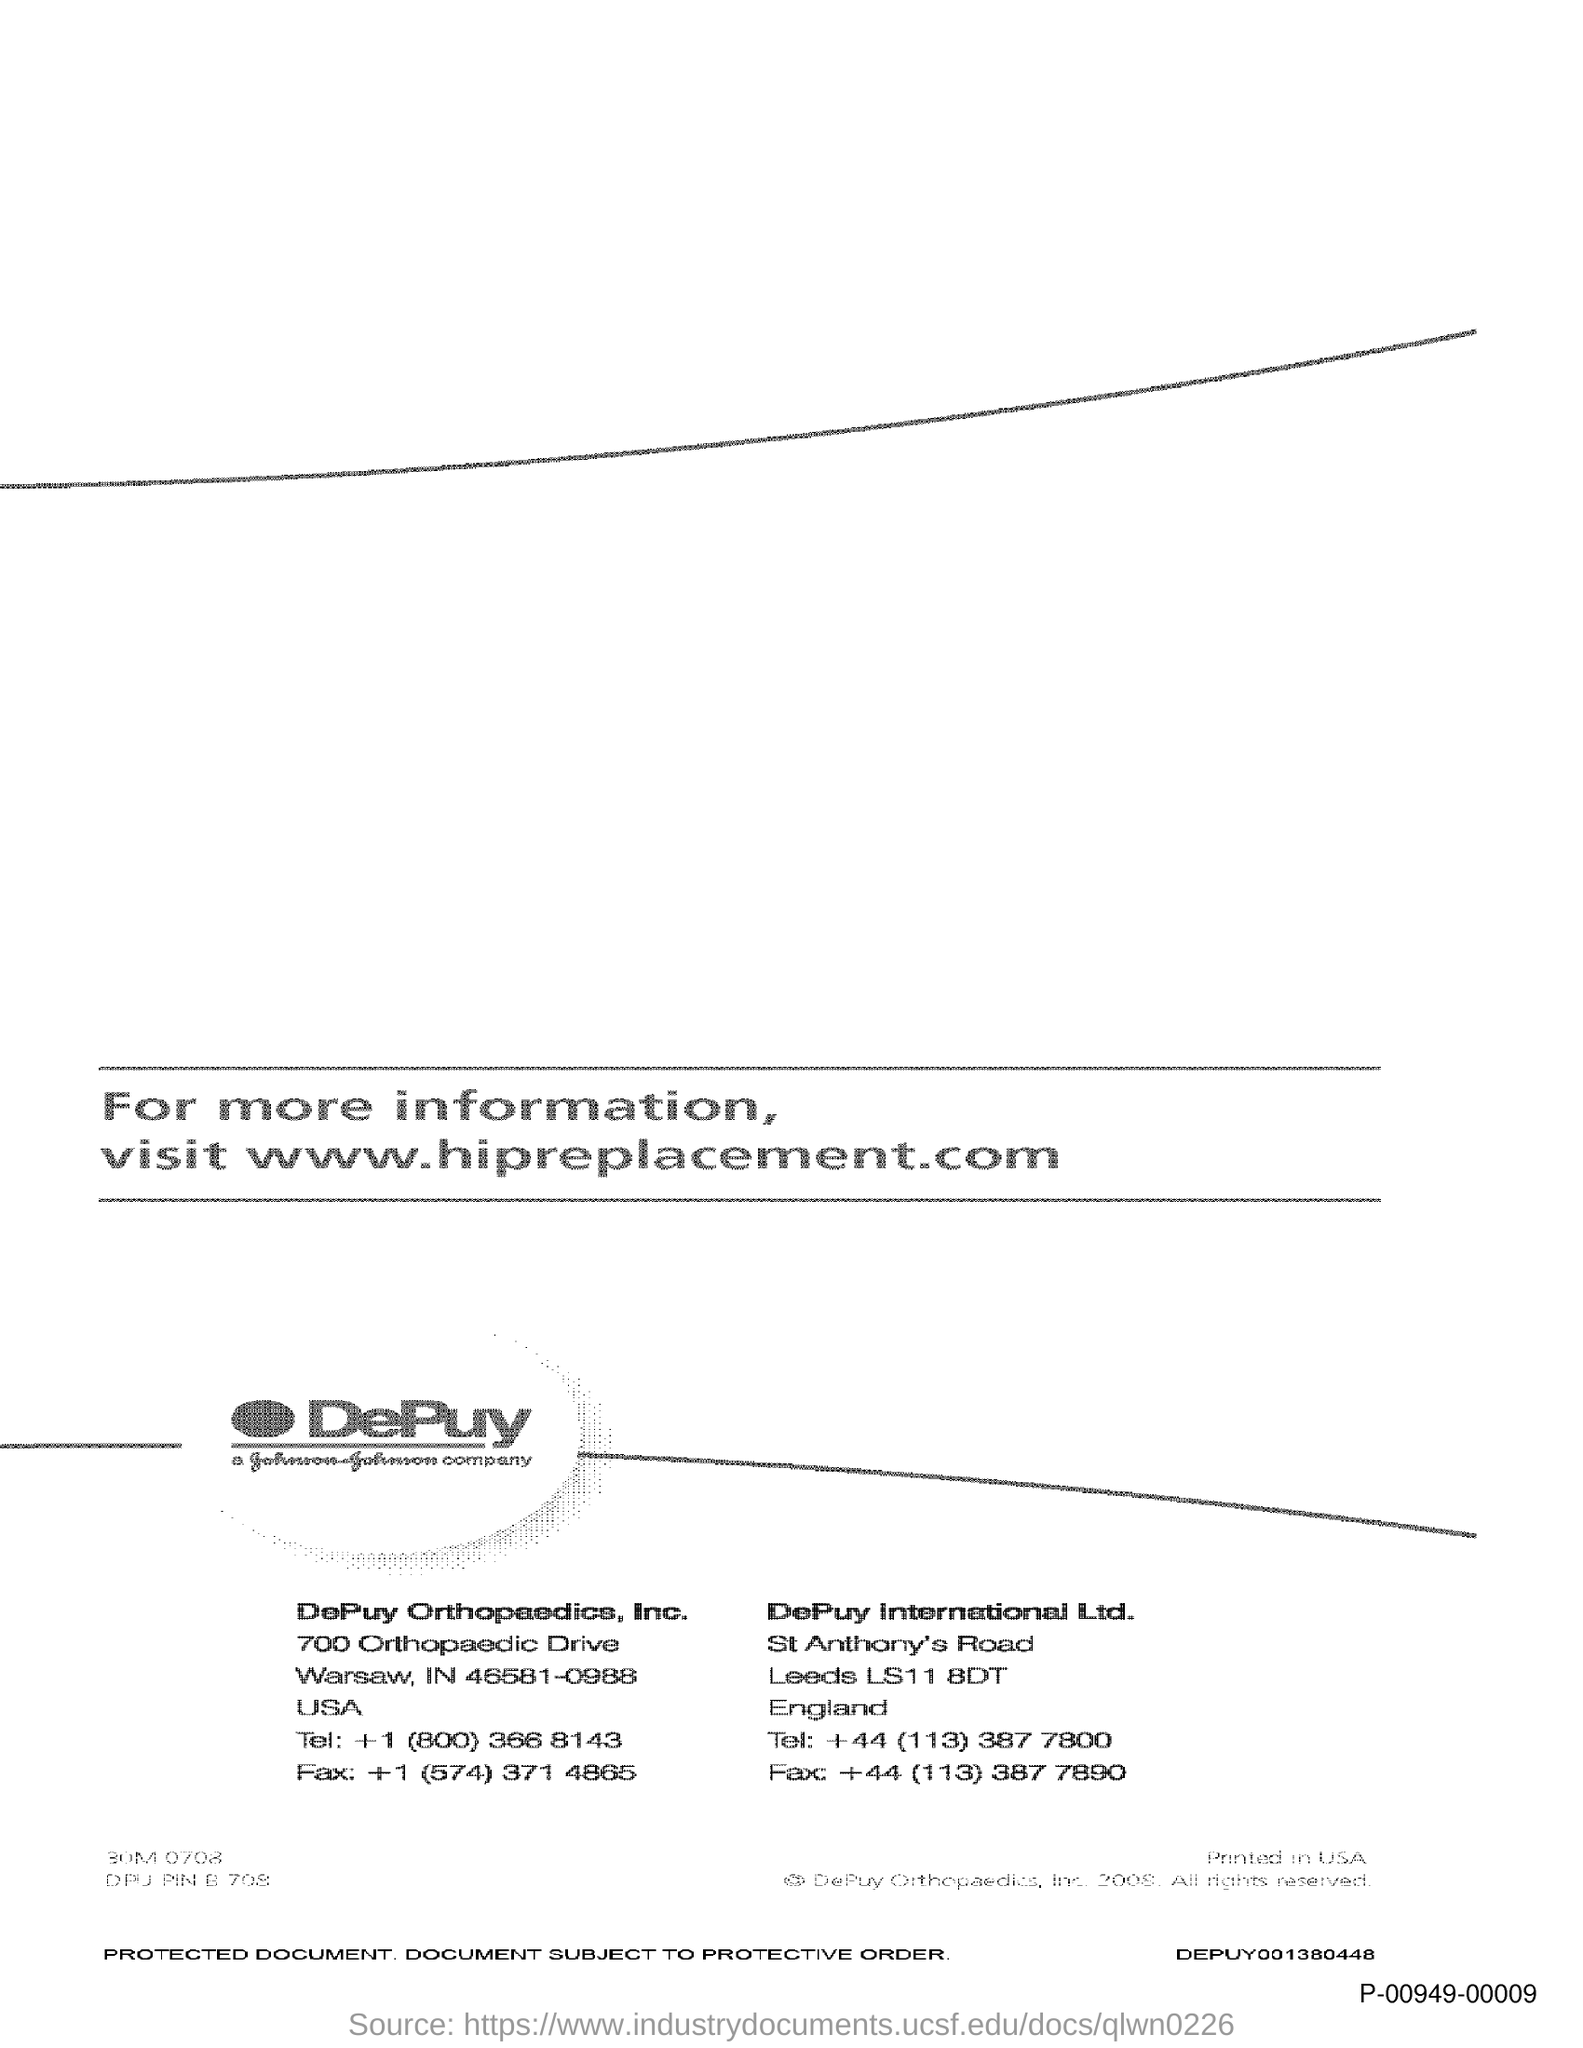Highlight a few significant elements in this photo. The Fax number for DePuy Orthopaedics, Inc is +1 (574) 371 4865. The fax number for DePuy International Ltd is +44 (113) 387 7890. 